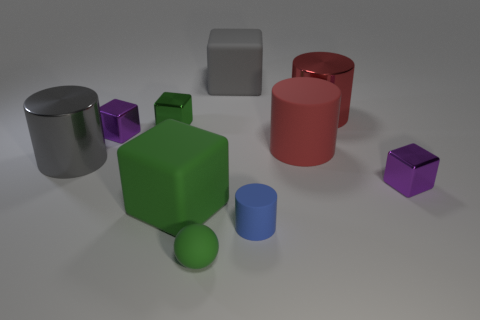What materials do the objects appear to be made of? The objects exhibit different material properties suggesting they could be made from various substances. The cubes and the cylinders have a matte finish, which could imply they are made from a type of painted or coated metal or plastic. The silver cylinder, in particular, has a reflective surface that resembles metal. The sphere's smooth surface and color are consistent with a matte painted finish, hinting at a similar manufacturing material as the cubes and cylinders. 